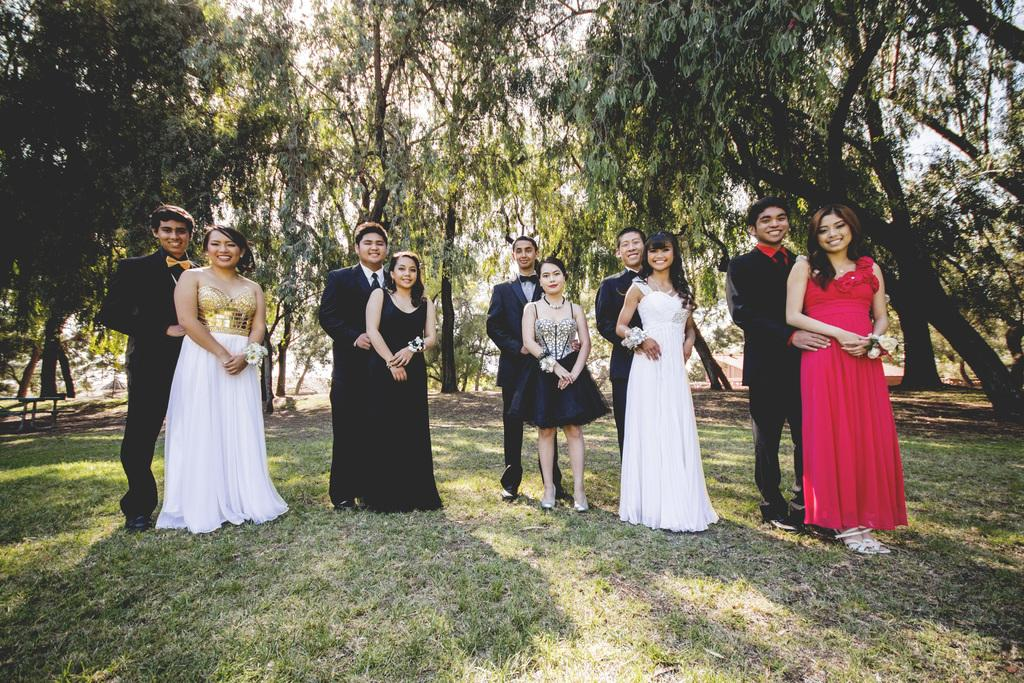How many people are in the image? There are five couples in the image, so there are 10 people in total. What are the couples doing in the image? The couples are standing on the ground and smiling. What is the ground covered with? The ground is covered with grass. What can be seen in the background of the image? There are trees and the sky visible in the background of the image. What type of ladybug can be seen on the plate in the image? There is no ladybug or plate present in the image. What flavor of eggnog is being served to the couples in the image? There is no eggnog present in the image. 